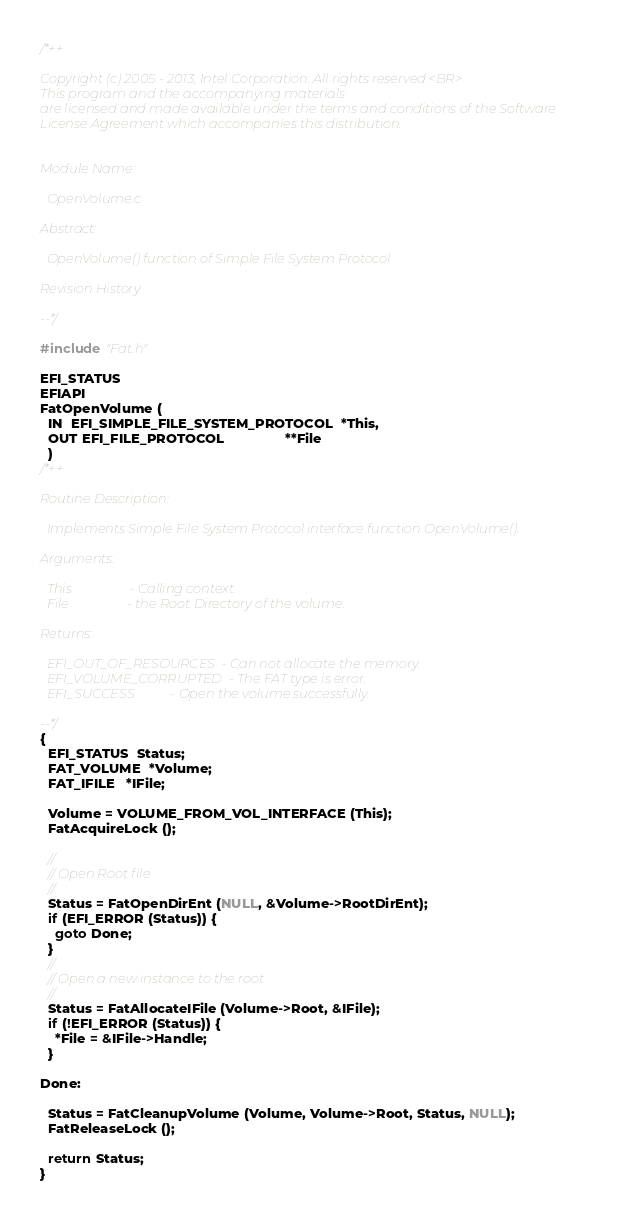Convert code to text. <code><loc_0><loc_0><loc_500><loc_500><_C_>/*++

Copyright (c) 2005 - 2013, Intel Corporation. All rights reserved.<BR>
This program and the accompanying materials
are licensed and made available under the terms and conditions of the Software
License Agreement which accompanies this distribution.


Module Name:

  OpenVolume.c

Abstract:

  OpenVolume() function of Simple File System Protocol

Revision History

--*/

#include "Fat.h"

EFI_STATUS
EFIAPI
FatOpenVolume (
  IN  EFI_SIMPLE_FILE_SYSTEM_PROTOCOL  *This,
  OUT EFI_FILE_PROTOCOL                **File
  )
/*++

Routine Description:

  Implements Simple File System Protocol interface function OpenVolume().

Arguments:

  This                  - Calling context.
  File                  - the Root Directory of the volume.

Returns:

  EFI_OUT_OF_RESOURCES  - Can not allocate the memory.
  EFI_VOLUME_CORRUPTED  - The FAT type is error.
  EFI_SUCCESS           - Open the volume successfully.

--*/
{
  EFI_STATUS  Status;
  FAT_VOLUME  *Volume;
  FAT_IFILE   *IFile;

  Volume = VOLUME_FROM_VOL_INTERFACE (This);
  FatAcquireLock ();

  //
  // Open Root file
  //
  Status = FatOpenDirEnt (NULL, &Volume->RootDirEnt);
  if (EFI_ERROR (Status)) {
    goto Done;
  }
  //
  // Open a new instance to the root
  //
  Status = FatAllocateIFile (Volume->Root, &IFile);
  if (!EFI_ERROR (Status)) {
    *File = &IFile->Handle;
  }

Done:

  Status = FatCleanupVolume (Volume, Volume->Root, Status, NULL);
  FatReleaseLock ();

  return Status;
}
</code> 